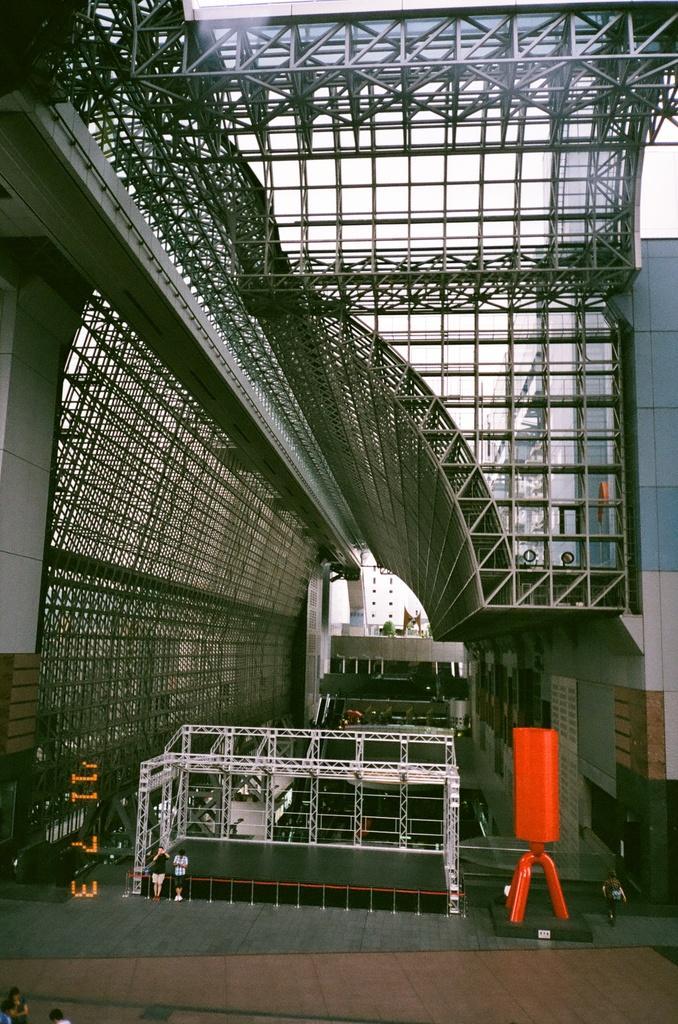Could you give a brief overview of what you see in this image? In this picture we can see people on the ground, here we can see metal rods, wall and some objects. 